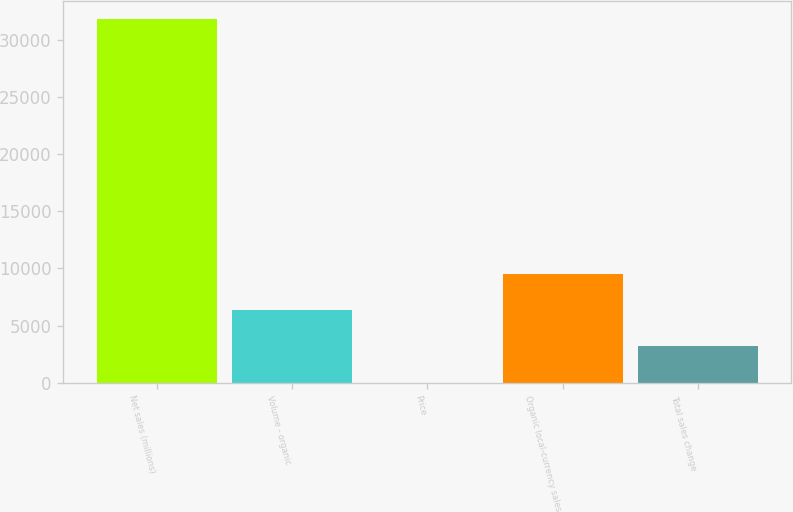Convert chart to OTSL. <chart><loc_0><loc_0><loc_500><loc_500><bar_chart><fcel>Net sales (millions)<fcel>Volume - organic<fcel>Price<fcel>Organic local-currency sales<fcel>Total sales change<nl><fcel>31821<fcel>6365<fcel>1<fcel>9547<fcel>3183<nl></chart> 